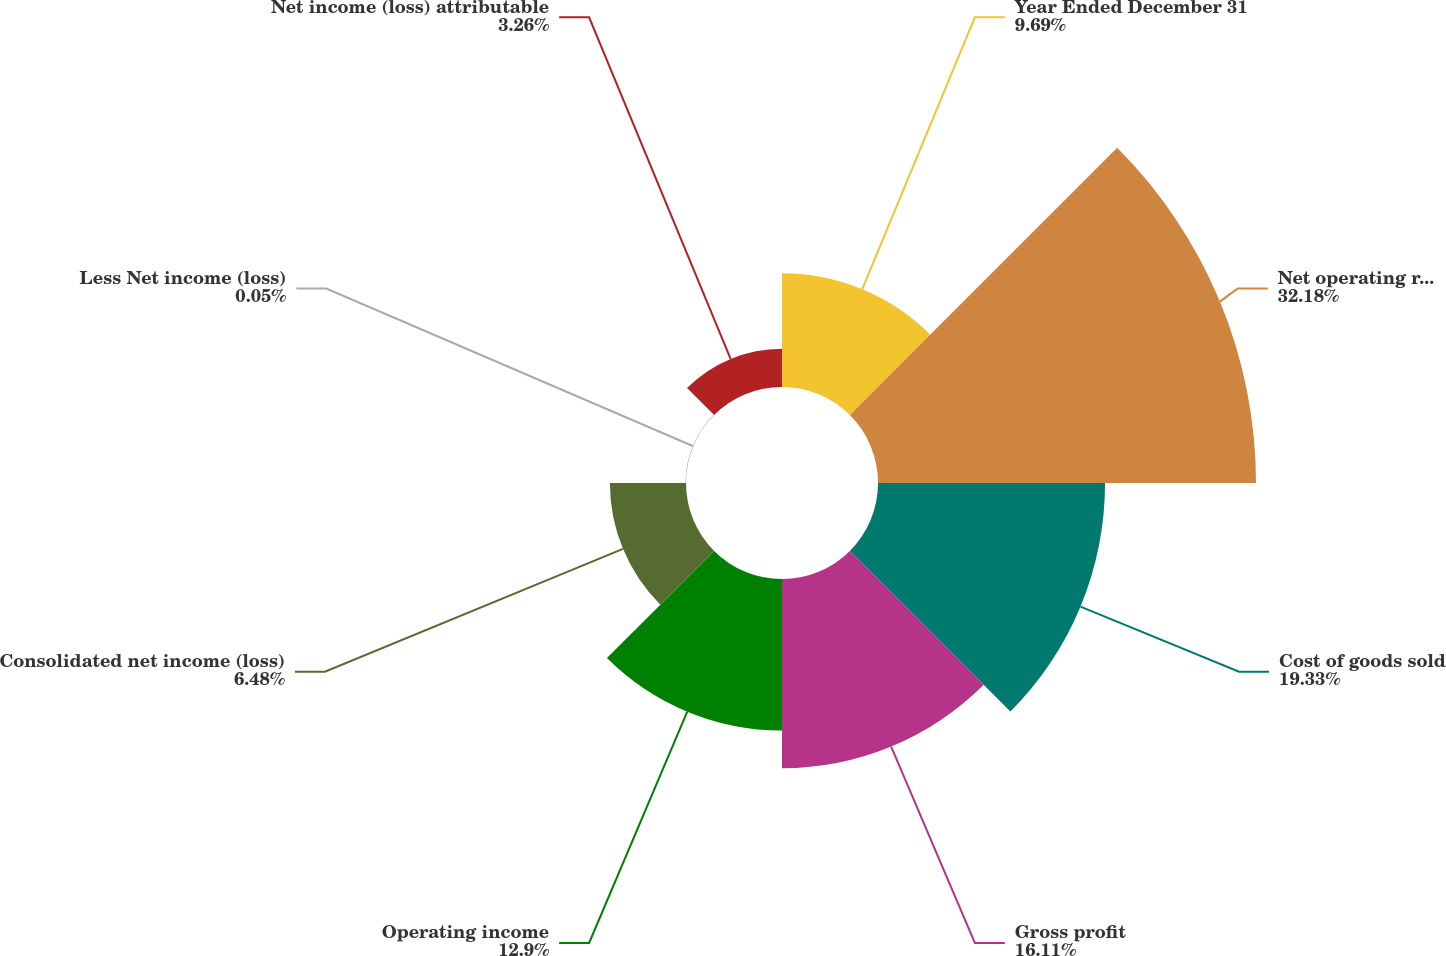<chart> <loc_0><loc_0><loc_500><loc_500><pie_chart><fcel>Year Ended December 31<fcel>Net operating revenues<fcel>Cost of goods sold<fcel>Gross profit<fcel>Operating income<fcel>Consolidated net income (loss)<fcel>Less Net income (loss)<fcel>Net income (loss) attributable<nl><fcel>9.69%<fcel>32.18%<fcel>19.33%<fcel>16.11%<fcel>12.9%<fcel>6.48%<fcel>0.05%<fcel>3.26%<nl></chart> 